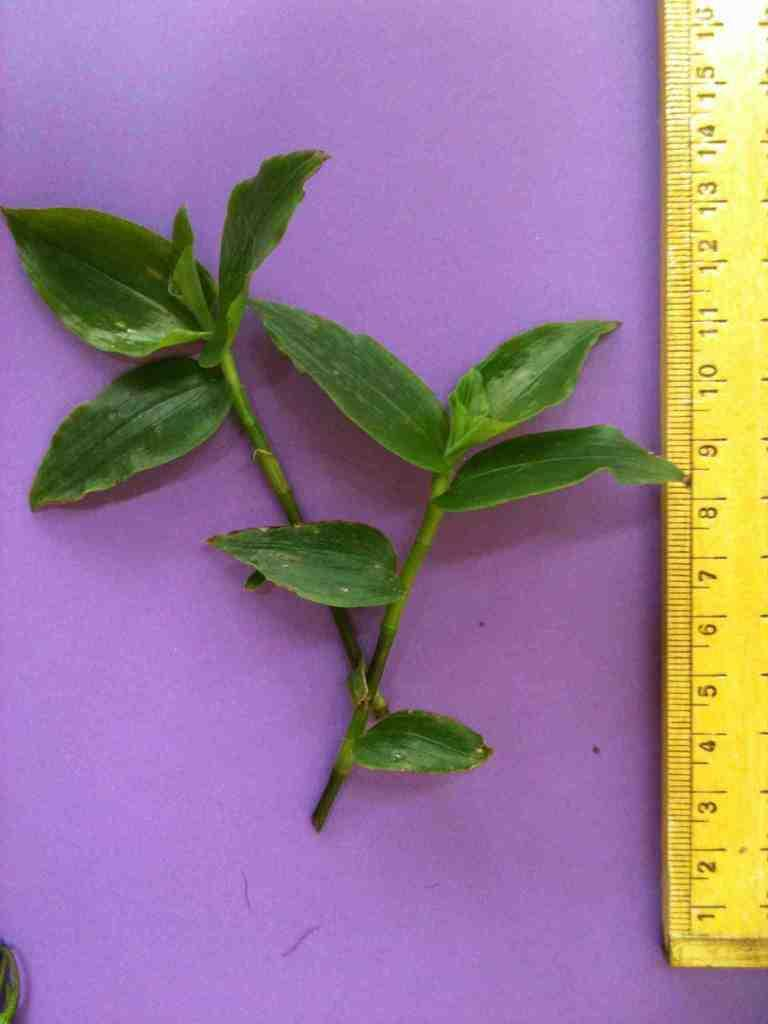<image>
Offer a succinct explanation of the picture presented. a leaf stem being measured by a yellow ruler as tall as 16 cm 